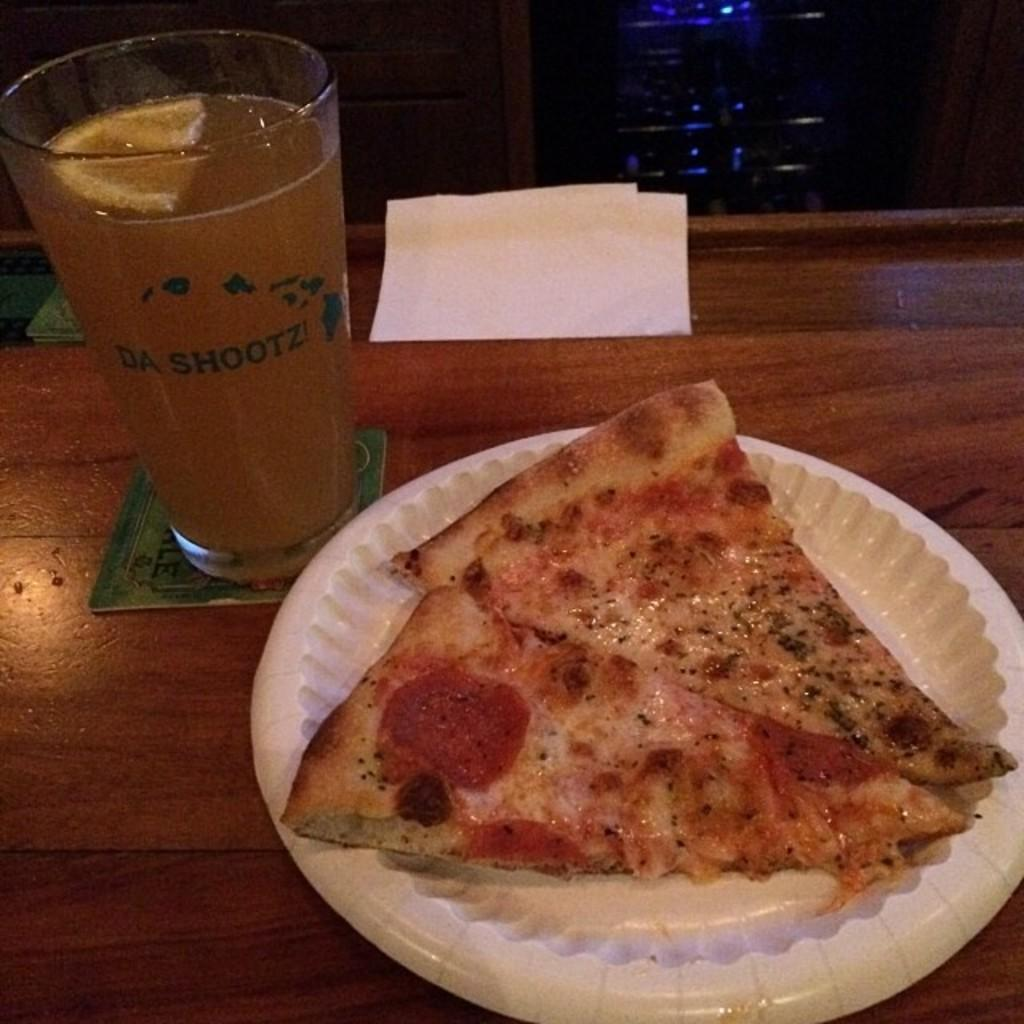What type of food is on the plate in the image? There are two pizza slices on a plate in the image. What can be found on the table besides the plate? There are tissues and coasters on the table. What type of beverage is in the glass on the table? There is a glass of juice on the table. What else can be seen in the image besides the items on the table? There are items visible in the background. How many cows are visible in the image? There are no cows visible in the image. What type of hook is being used to hold the pizza slices in the image? There is no hook present in the image; the pizza slices are on a plate. 